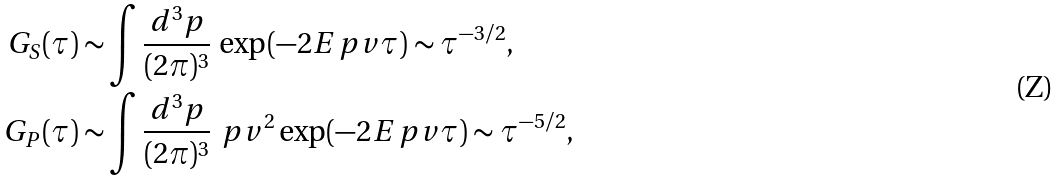Convert formula to latex. <formula><loc_0><loc_0><loc_500><loc_500>G _ { S } ( \tau ) \sim & \int \frac { d ^ { 3 } p } { ( 2 \pi ) ^ { 3 } } \, \exp ( - 2 E _ { \ } p v \tau ) \sim \tau ^ { - 3 / 2 } , \\ G _ { P } ( \tau ) \sim & \int \frac { d ^ { 3 } p } { ( 2 \pi ) ^ { 3 } } \, \ p v ^ { 2 } \exp ( - 2 E _ { \ } p v \tau ) \sim \tau ^ { - 5 / 2 } ,</formula> 